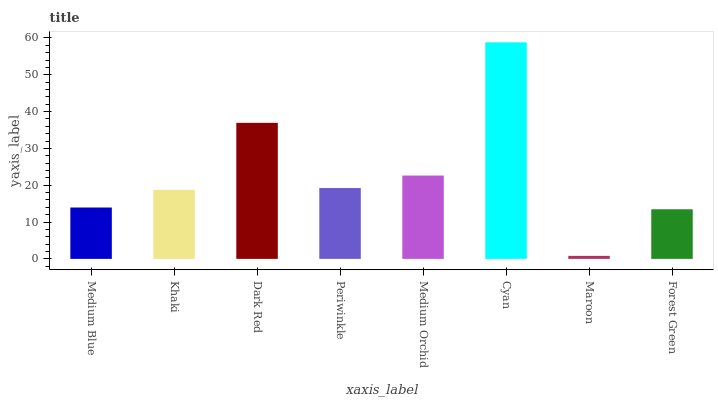Is Maroon the minimum?
Answer yes or no. Yes. Is Cyan the maximum?
Answer yes or no. Yes. Is Khaki the minimum?
Answer yes or no. No. Is Khaki the maximum?
Answer yes or no. No. Is Khaki greater than Medium Blue?
Answer yes or no. Yes. Is Medium Blue less than Khaki?
Answer yes or no. Yes. Is Medium Blue greater than Khaki?
Answer yes or no. No. Is Khaki less than Medium Blue?
Answer yes or no. No. Is Periwinkle the high median?
Answer yes or no. Yes. Is Khaki the low median?
Answer yes or no. Yes. Is Khaki the high median?
Answer yes or no. No. Is Medium Blue the low median?
Answer yes or no. No. 